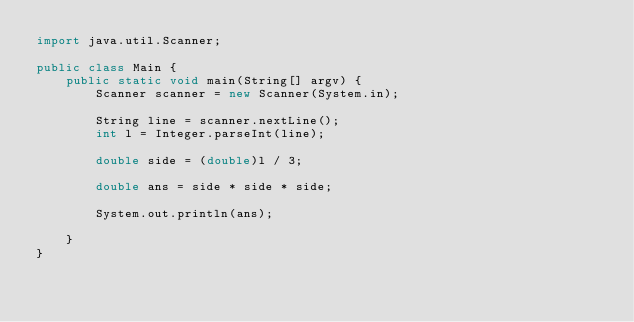Convert code to text. <code><loc_0><loc_0><loc_500><loc_500><_Java_>import java.util.Scanner;

public class Main {
    public static void main(String[] argv) {
        Scanner scanner = new Scanner(System.in);

        String line = scanner.nextLine();
        int l = Integer.parseInt(line);

        double side = (double)l / 3;

        double ans = side * side * side;

        System.out.println(ans);

    }
}</code> 